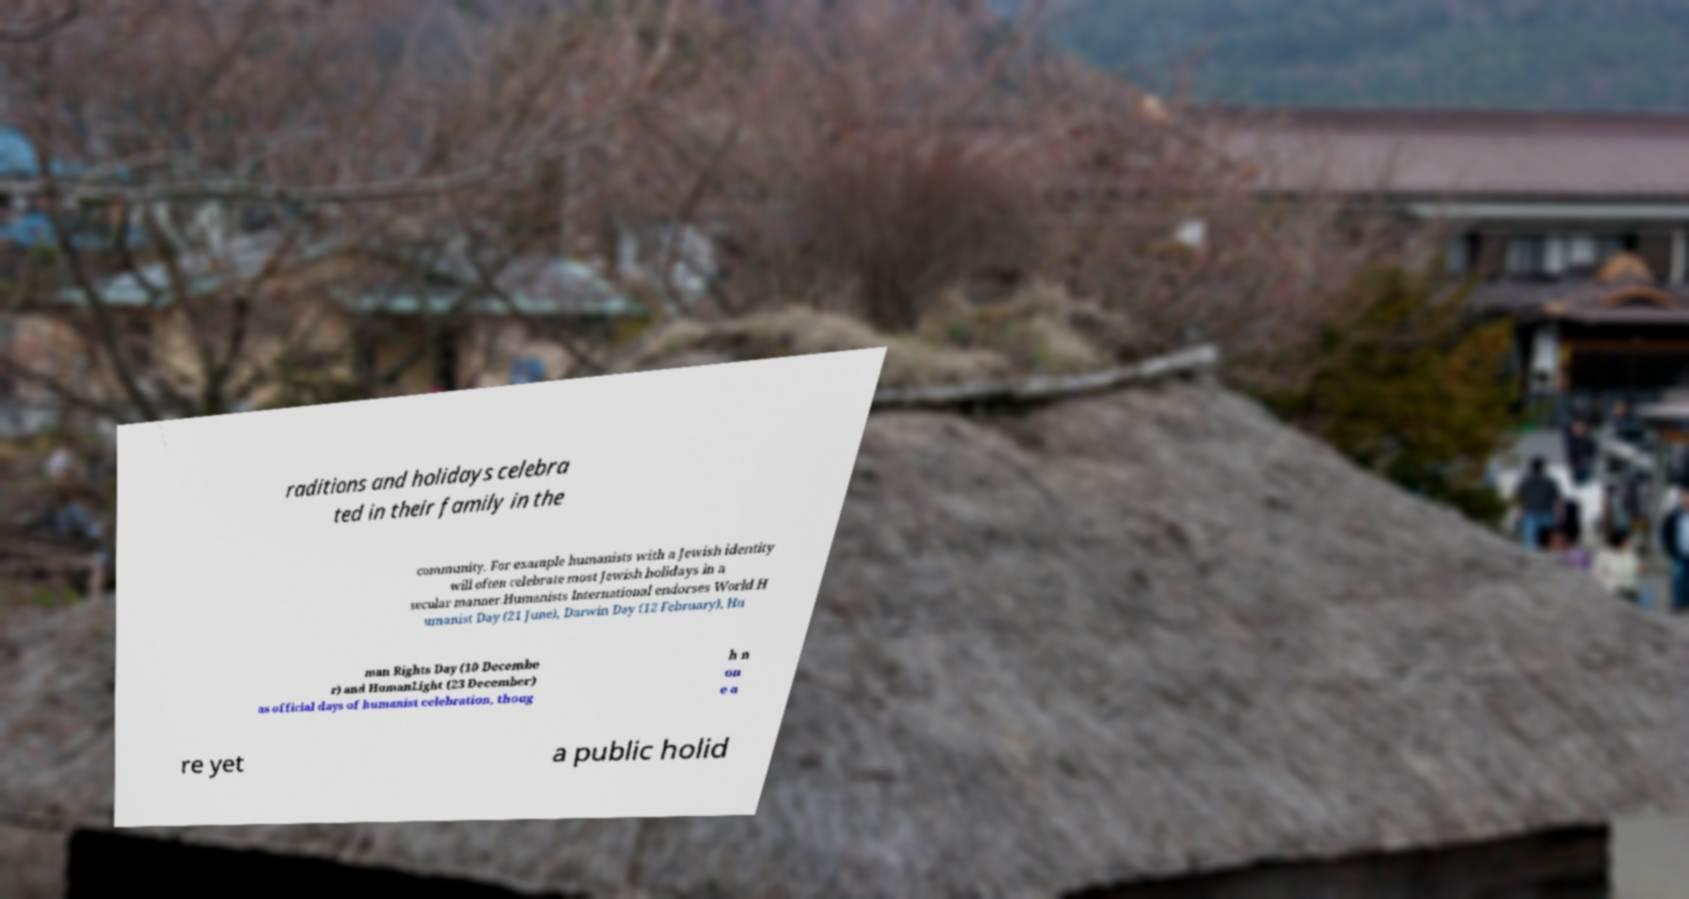Can you read and provide the text displayed in the image?This photo seems to have some interesting text. Can you extract and type it out for me? raditions and holidays celebra ted in their family in the community. For example humanists with a Jewish identity will often celebrate most Jewish holidays in a secular manner.Humanists International endorses World H umanist Day (21 June), Darwin Day (12 February), Hu man Rights Day (10 Decembe r) and HumanLight (23 December) as official days of humanist celebration, thoug h n on e a re yet a public holid 